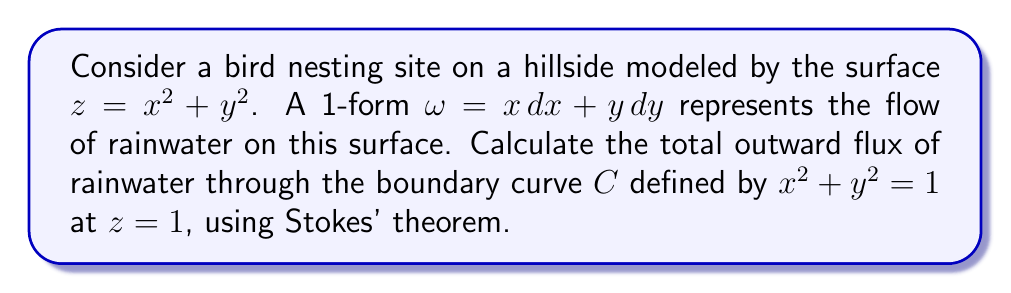Give your solution to this math problem. 1) First, we need to understand that Stokes' theorem relates the integral of a differential form $\omega$ over the boundary of a surface to the integral of its exterior derivative $d\omega$ over the surface itself:

   $$\int_C \omega = \int_S d\omega$$

2) We are given $\omega = x dx + y dy$. Let's calculate $d\omega$:
   
   $$d\omega = d(x dx + y dy) = dx \wedge dx + dy \wedge dy + x d(dx) + y d(dy) = 0 + 0 + dx \wedge dy + dy \wedge dx = 2 dx \wedge dy$$

3) Now we need to parametrize the surface $S$ bounded by $C$. We can use polar coordinates:
   
   $x = r \cos\theta$, $y = r \sin\theta$, where $0 \leq r \leq 1$ and $0 \leq \theta \leq 2\pi$

4) The surface element in these coordinates is:
   
   $$dx \wedge dy = r dr \wedge d\theta$$

5) Substituting this into our integral:

   $$\int_S d\omega = \int_S 2 dx \wedge dy = \int_0^{2\pi} \int_0^1 2r dr d\theta$$

6) Evaluating the integral:

   $$\int_0^{2\pi} \int_0^1 2r dr d\theta = 2\pi \int_0^1 2r dr = 2\pi [r^2]_0^1 = 2\pi$$

7) Therefore, by Stokes' theorem, the flux through the boundary curve $C$ is also $2\pi$.
Answer: $2\pi$ 